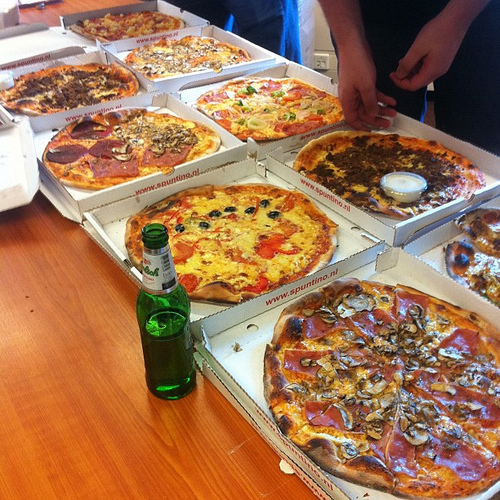Are there hamburgers in this photo? No, there are no hamburgers in this photo. 